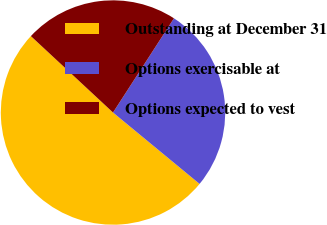Convert chart. <chart><loc_0><loc_0><loc_500><loc_500><pie_chart><fcel>Outstanding at December 31<fcel>Options exercisable at<fcel>Options expected to vest<nl><fcel>50.95%<fcel>26.84%<fcel>22.21%<nl></chart> 